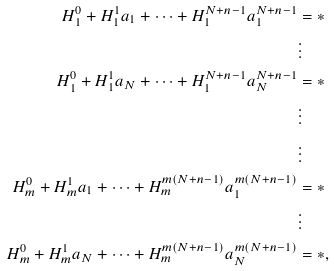Convert formula to latex. <formula><loc_0><loc_0><loc_500><loc_500>H _ { 1 } ^ { 0 } + H _ { 1 } ^ { 1 } a _ { 1 } + \cdots + H _ { 1 } ^ { N + n - 1 } a _ { 1 } ^ { N + n - 1 } & = * \\ & \vdots \\ H _ { 1 } ^ { 0 } + H _ { 1 } ^ { 1 } a _ { N } + \cdots + H _ { 1 } ^ { N + n - 1 } a _ { N } ^ { N + n - 1 } & = * \\ & \vdots \\ & \vdots \\ H _ { m } ^ { 0 } + H _ { m } ^ { 1 } a _ { 1 } + \cdots + H _ { m } ^ { m ( N + n - 1 ) } a _ { 1 } ^ { m ( N + n - 1 ) } & = * \\ & \vdots \\ H _ { m } ^ { 0 } + H _ { m } ^ { 1 } a _ { N } + \cdots + H _ { m } ^ { m ( N + n - 1 ) } a _ { N } ^ { m ( N + n - 1 ) } & = * ,</formula> 